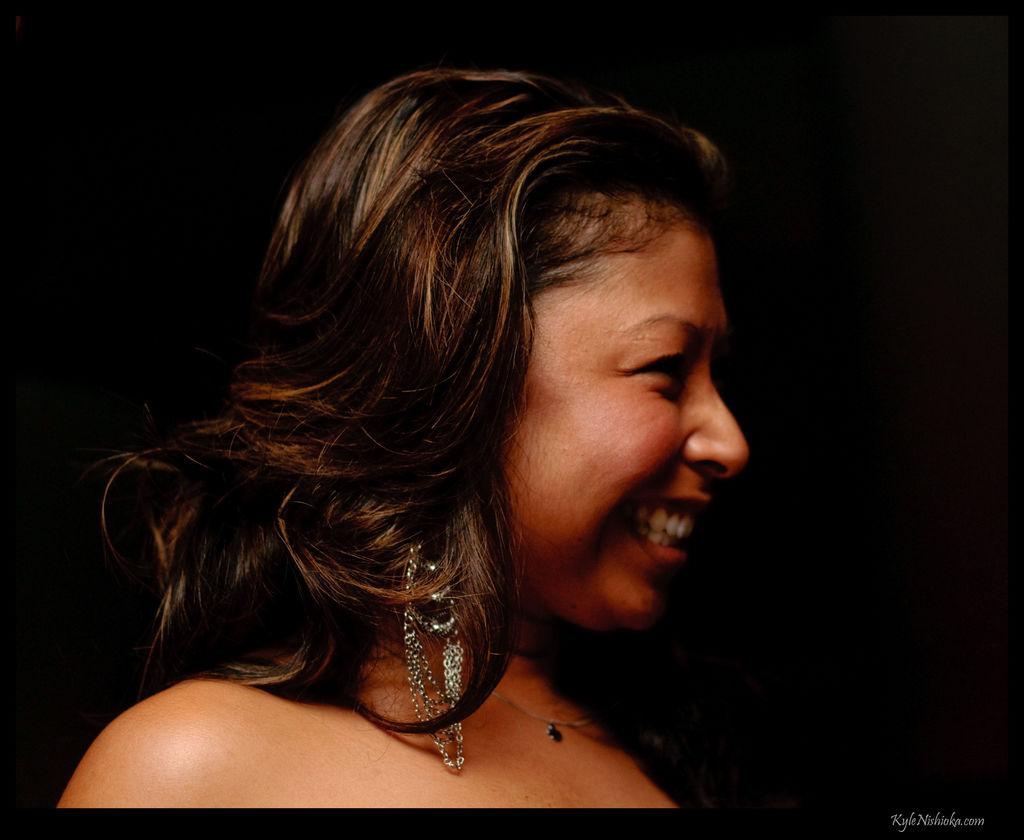Who is the main subject in the foreground of the image? There is a woman in the foreground of the image. What can be observed about the background of the image? The background of the image is dark. What type of guide is the woman holding in the image? There is no guide present in the image; the woman is the main subject in the foreground. Can you tell me how many chess pieces are visible on the table in the image? There is no table or chess pieces present in the image. What color is the sweater the woman is wearing in the image? The provided facts do not mention the color of the woman's clothing, so we cannot determine the color of her sweater. 